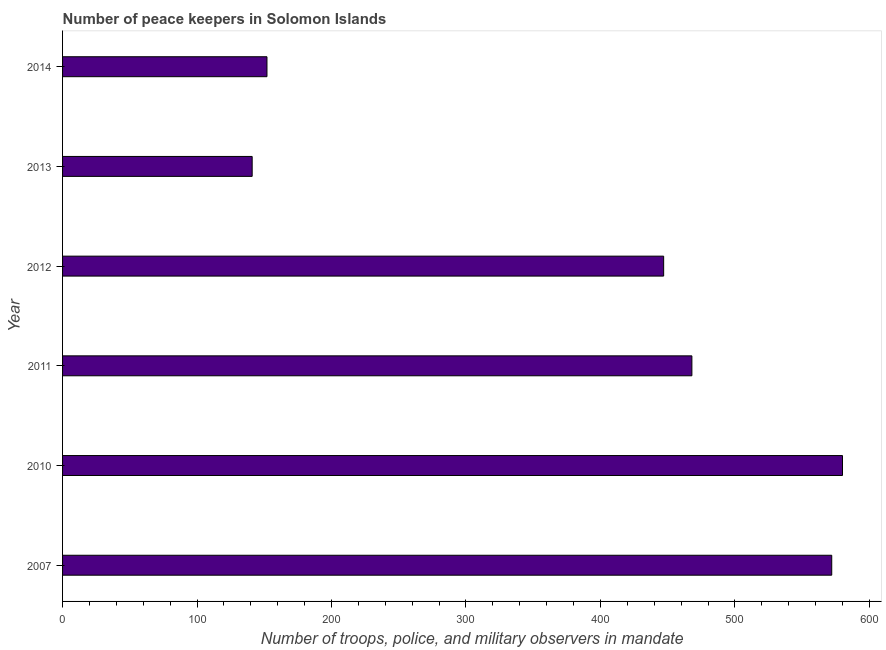Does the graph contain grids?
Make the answer very short. No. What is the title of the graph?
Your answer should be compact. Number of peace keepers in Solomon Islands. What is the label or title of the X-axis?
Your answer should be very brief. Number of troops, police, and military observers in mandate. What is the label or title of the Y-axis?
Your answer should be compact. Year. What is the number of peace keepers in 2014?
Offer a very short reply. 152. Across all years, what is the maximum number of peace keepers?
Your answer should be very brief. 580. Across all years, what is the minimum number of peace keepers?
Offer a very short reply. 141. In which year was the number of peace keepers maximum?
Offer a terse response. 2010. What is the sum of the number of peace keepers?
Provide a short and direct response. 2360. What is the difference between the number of peace keepers in 2010 and 2013?
Your answer should be compact. 439. What is the average number of peace keepers per year?
Provide a short and direct response. 393. What is the median number of peace keepers?
Offer a very short reply. 457.5. Do a majority of the years between 2010 and 2013 (inclusive) have number of peace keepers greater than 140 ?
Your answer should be very brief. Yes. What is the ratio of the number of peace keepers in 2011 to that in 2013?
Give a very brief answer. 3.32. What is the difference between the highest and the second highest number of peace keepers?
Your response must be concise. 8. What is the difference between the highest and the lowest number of peace keepers?
Offer a terse response. 439. How many bars are there?
Your response must be concise. 6. Are all the bars in the graph horizontal?
Offer a very short reply. Yes. What is the difference between two consecutive major ticks on the X-axis?
Provide a short and direct response. 100. What is the Number of troops, police, and military observers in mandate in 2007?
Your answer should be very brief. 572. What is the Number of troops, police, and military observers in mandate in 2010?
Your answer should be very brief. 580. What is the Number of troops, police, and military observers in mandate of 2011?
Make the answer very short. 468. What is the Number of troops, police, and military observers in mandate in 2012?
Provide a short and direct response. 447. What is the Number of troops, police, and military observers in mandate of 2013?
Your response must be concise. 141. What is the Number of troops, police, and military observers in mandate in 2014?
Your response must be concise. 152. What is the difference between the Number of troops, police, and military observers in mandate in 2007 and 2011?
Keep it short and to the point. 104. What is the difference between the Number of troops, police, and military observers in mandate in 2007 and 2012?
Provide a short and direct response. 125. What is the difference between the Number of troops, police, and military observers in mandate in 2007 and 2013?
Your answer should be compact. 431. What is the difference between the Number of troops, police, and military observers in mandate in 2007 and 2014?
Provide a short and direct response. 420. What is the difference between the Number of troops, police, and military observers in mandate in 2010 and 2011?
Offer a terse response. 112. What is the difference between the Number of troops, police, and military observers in mandate in 2010 and 2012?
Provide a short and direct response. 133. What is the difference between the Number of troops, police, and military observers in mandate in 2010 and 2013?
Give a very brief answer. 439. What is the difference between the Number of troops, police, and military observers in mandate in 2010 and 2014?
Give a very brief answer. 428. What is the difference between the Number of troops, police, and military observers in mandate in 2011 and 2012?
Offer a terse response. 21. What is the difference between the Number of troops, police, and military observers in mandate in 2011 and 2013?
Give a very brief answer. 327. What is the difference between the Number of troops, police, and military observers in mandate in 2011 and 2014?
Keep it short and to the point. 316. What is the difference between the Number of troops, police, and military observers in mandate in 2012 and 2013?
Offer a very short reply. 306. What is the difference between the Number of troops, police, and military observers in mandate in 2012 and 2014?
Keep it short and to the point. 295. What is the ratio of the Number of troops, police, and military observers in mandate in 2007 to that in 2011?
Give a very brief answer. 1.22. What is the ratio of the Number of troops, police, and military observers in mandate in 2007 to that in 2012?
Your answer should be very brief. 1.28. What is the ratio of the Number of troops, police, and military observers in mandate in 2007 to that in 2013?
Provide a succinct answer. 4.06. What is the ratio of the Number of troops, police, and military observers in mandate in 2007 to that in 2014?
Offer a terse response. 3.76. What is the ratio of the Number of troops, police, and military observers in mandate in 2010 to that in 2011?
Keep it short and to the point. 1.24. What is the ratio of the Number of troops, police, and military observers in mandate in 2010 to that in 2012?
Your answer should be compact. 1.3. What is the ratio of the Number of troops, police, and military observers in mandate in 2010 to that in 2013?
Offer a very short reply. 4.11. What is the ratio of the Number of troops, police, and military observers in mandate in 2010 to that in 2014?
Offer a very short reply. 3.82. What is the ratio of the Number of troops, police, and military observers in mandate in 2011 to that in 2012?
Give a very brief answer. 1.05. What is the ratio of the Number of troops, police, and military observers in mandate in 2011 to that in 2013?
Make the answer very short. 3.32. What is the ratio of the Number of troops, police, and military observers in mandate in 2011 to that in 2014?
Ensure brevity in your answer.  3.08. What is the ratio of the Number of troops, police, and military observers in mandate in 2012 to that in 2013?
Your response must be concise. 3.17. What is the ratio of the Number of troops, police, and military observers in mandate in 2012 to that in 2014?
Offer a very short reply. 2.94. What is the ratio of the Number of troops, police, and military observers in mandate in 2013 to that in 2014?
Provide a succinct answer. 0.93. 